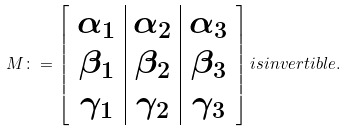Convert formula to latex. <formula><loc_0><loc_0><loc_500><loc_500>M \colon = \left [ \begin{array} { c | c | c } \alpha _ { 1 } & \alpha _ { 2 } & \alpha _ { 3 } \\ \beta _ { 1 } & \beta _ { 2 } & \beta _ { 3 } \\ \gamma _ { 1 } & \gamma _ { 2 } & \gamma _ { 3 } \\ \end{array} \right ] i s i n v e r t i b l e .</formula> 